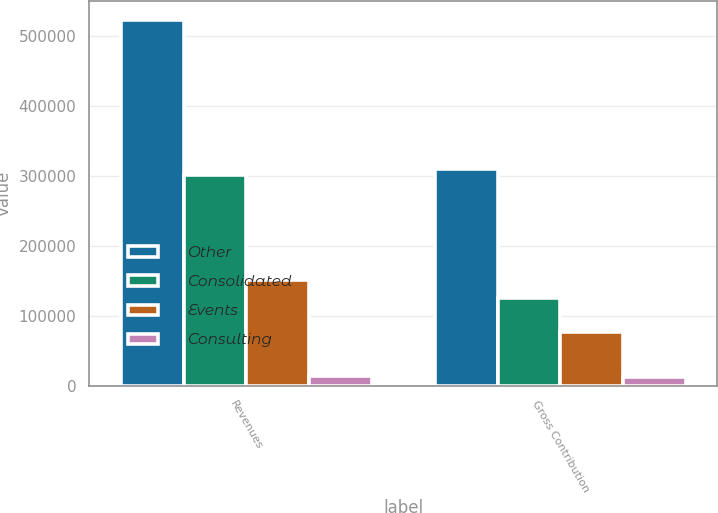Convert chart to OTSL. <chart><loc_0><loc_0><loc_500><loc_500><stacked_bar_chart><ecel><fcel>Revenues<fcel>Gross Contribution<nl><fcel>Other<fcel>523033<fcel>310008<nl><fcel>Consolidated<fcel>301074<fcel>125678<nl><fcel>Events<fcel>151339<fcel>76135<nl><fcel>Consulting<fcel>13558<fcel>12184<nl></chart> 